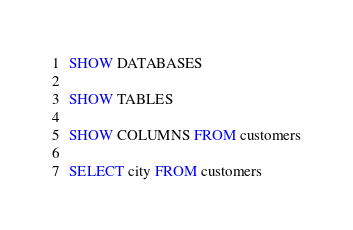<code> <loc_0><loc_0><loc_500><loc_500><_SQL_>SHOW DATABASES

SHOW TABLES

SHOW COLUMNS FROM customers

SELECT city FROM customers</code> 